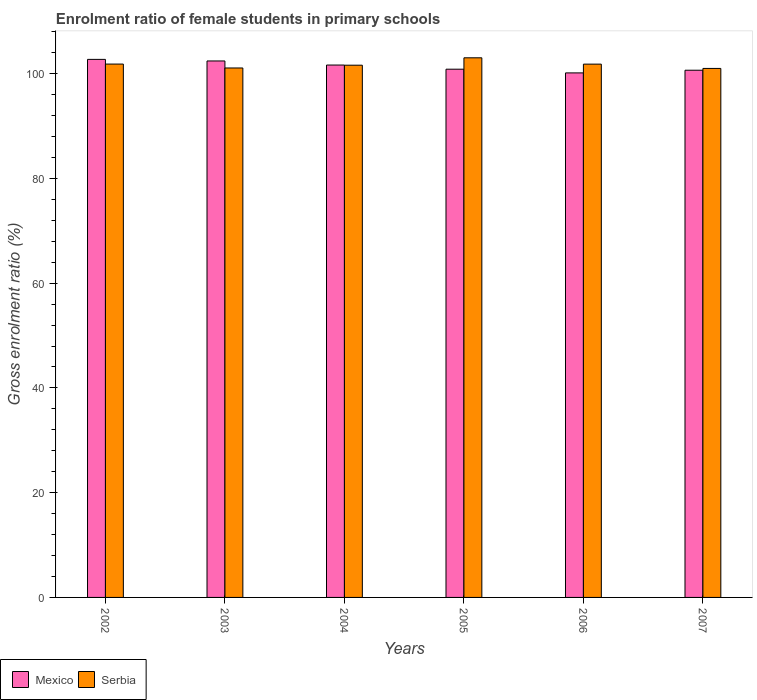How many groups of bars are there?
Make the answer very short. 6. Are the number of bars per tick equal to the number of legend labels?
Your answer should be very brief. Yes. Are the number of bars on each tick of the X-axis equal?
Make the answer very short. Yes. How many bars are there on the 4th tick from the left?
Your response must be concise. 2. What is the enrolment ratio of female students in primary schools in Serbia in 2004?
Give a very brief answer. 101.61. Across all years, what is the maximum enrolment ratio of female students in primary schools in Serbia?
Provide a short and direct response. 103.02. Across all years, what is the minimum enrolment ratio of female students in primary schools in Mexico?
Offer a terse response. 100.14. In which year was the enrolment ratio of female students in primary schools in Mexico maximum?
Your answer should be very brief. 2002. What is the total enrolment ratio of female students in primary schools in Mexico in the graph?
Your answer should be very brief. 608.43. What is the difference between the enrolment ratio of female students in primary schools in Serbia in 2002 and that in 2007?
Your response must be concise. 0.83. What is the difference between the enrolment ratio of female students in primary schools in Mexico in 2007 and the enrolment ratio of female students in primary schools in Serbia in 2004?
Ensure brevity in your answer.  -0.96. What is the average enrolment ratio of female students in primary schools in Mexico per year?
Offer a terse response. 101.4. In the year 2005, what is the difference between the enrolment ratio of female students in primary schools in Mexico and enrolment ratio of female students in primary schools in Serbia?
Your answer should be very brief. -2.17. What is the ratio of the enrolment ratio of female students in primary schools in Mexico in 2002 to that in 2005?
Keep it short and to the point. 1.02. Is the enrolment ratio of female students in primary schools in Mexico in 2005 less than that in 2006?
Make the answer very short. No. What is the difference between the highest and the second highest enrolment ratio of female students in primary schools in Serbia?
Provide a succinct answer. 1.2. What is the difference between the highest and the lowest enrolment ratio of female students in primary schools in Serbia?
Provide a short and direct response. 2.03. In how many years, is the enrolment ratio of female students in primary schools in Serbia greater than the average enrolment ratio of female students in primary schools in Serbia taken over all years?
Your answer should be compact. 3. How many years are there in the graph?
Offer a very short reply. 6. Are the values on the major ticks of Y-axis written in scientific E-notation?
Provide a short and direct response. No. How many legend labels are there?
Your answer should be very brief. 2. What is the title of the graph?
Your answer should be compact. Enrolment ratio of female students in primary schools. What is the label or title of the Y-axis?
Offer a very short reply. Gross enrolment ratio (%). What is the Gross enrolment ratio (%) in Mexico in 2002?
Ensure brevity in your answer.  102.72. What is the Gross enrolment ratio (%) of Serbia in 2002?
Your answer should be very brief. 101.83. What is the Gross enrolment ratio (%) in Mexico in 2003?
Offer a terse response. 102.42. What is the Gross enrolment ratio (%) in Serbia in 2003?
Ensure brevity in your answer.  101.08. What is the Gross enrolment ratio (%) of Mexico in 2004?
Give a very brief answer. 101.64. What is the Gross enrolment ratio (%) of Serbia in 2004?
Give a very brief answer. 101.61. What is the Gross enrolment ratio (%) of Mexico in 2005?
Give a very brief answer. 100.85. What is the Gross enrolment ratio (%) in Serbia in 2005?
Ensure brevity in your answer.  103.02. What is the Gross enrolment ratio (%) in Mexico in 2006?
Give a very brief answer. 100.14. What is the Gross enrolment ratio (%) of Serbia in 2006?
Your answer should be compact. 101.82. What is the Gross enrolment ratio (%) in Mexico in 2007?
Offer a very short reply. 100.65. What is the Gross enrolment ratio (%) of Serbia in 2007?
Your answer should be very brief. 101. Across all years, what is the maximum Gross enrolment ratio (%) in Mexico?
Your answer should be compact. 102.72. Across all years, what is the maximum Gross enrolment ratio (%) in Serbia?
Your response must be concise. 103.02. Across all years, what is the minimum Gross enrolment ratio (%) of Mexico?
Offer a very short reply. 100.14. Across all years, what is the minimum Gross enrolment ratio (%) of Serbia?
Keep it short and to the point. 101. What is the total Gross enrolment ratio (%) in Mexico in the graph?
Your answer should be very brief. 608.43. What is the total Gross enrolment ratio (%) of Serbia in the graph?
Give a very brief answer. 610.36. What is the difference between the Gross enrolment ratio (%) of Mexico in 2002 and that in 2003?
Provide a short and direct response. 0.3. What is the difference between the Gross enrolment ratio (%) of Serbia in 2002 and that in 2003?
Make the answer very short. 0.75. What is the difference between the Gross enrolment ratio (%) in Mexico in 2002 and that in 2004?
Offer a very short reply. 1.08. What is the difference between the Gross enrolment ratio (%) in Serbia in 2002 and that in 2004?
Offer a very short reply. 0.22. What is the difference between the Gross enrolment ratio (%) of Mexico in 2002 and that in 2005?
Offer a very short reply. 1.87. What is the difference between the Gross enrolment ratio (%) of Serbia in 2002 and that in 2005?
Provide a succinct answer. -1.2. What is the difference between the Gross enrolment ratio (%) of Mexico in 2002 and that in 2006?
Provide a succinct answer. 2.58. What is the difference between the Gross enrolment ratio (%) in Serbia in 2002 and that in 2006?
Make the answer very short. 0.01. What is the difference between the Gross enrolment ratio (%) of Mexico in 2002 and that in 2007?
Your answer should be compact. 2.07. What is the difference between the Gross enrolment ratio (%) in Serbia in 2002 and that in 2007?
Ensure brevity in your answer.  0.83. What is the difference between the Gross enrolment ratio (%) in Mexico in 2003 and that in 2004?
Make the answer very short. 0.78. What is the difference between the Gross enrolment ratio (%) of Serbia in 2003 and that in 2004?
Keep it short and to the point. -0.53. What is the difference between the Gross enrolment ratio (%) in Mexico in 2003 and that in 2005?
Give a very brief answer. 1.57. What is the difference between the Gross enrolment ratio (%) of Serbia in 2003 and that in 2005?
Offer a terse response. -1.94. What is the difference between the Gross enrolment ratio (%) in Mexico in 2003 and that in 2006?
Your answer should be very brief. 2.28. What is the difference between the Gross enrolment ratio (%) in Serbia in 2003 and that in 2006?
Your answer should be compact. -0.73. What is the difference between the Gross enrolment ratio (%) in Mexico in 2003 and that in 2007?
Provide a succinct answer. 1.77. What is the difference between the Gross enrolment ratio (%) of Serbia in 2003 and that in 2007?
Provide a short and direct response. 0.09. What is the difference between the Gross enrolment ratio (%) of Mexico in 2004 and that in 2005?
Provide a short and direct response. 0.79. What is the difference between the Gross enrolment ratio (%) in Serbia in 2004 and that in 2005?
Your answer should be very brief. -1.41. What is the difference between the Gross enrolment ratio (%) of Mexico in 2004 and that in 2006?
Provide a succinct answer. 1.5. What is the difference between the Gross enrolment ratio (%) in Serbia in 2004 and that in 2006?
Offer a terse response. -0.2. What is the difference between the Gross enrolment ratio (%) of Mexico in 2004 and that in 2007?
Make the answer very short. 0.99. What is the difference between the Gross enrolment ratio (%) of Serbia in 2004 and that in 2007?
Ensure brevity in your answer.  0.62. What is the difference between the Gross enrolment ratio (%) of Mexico in 2005 and that in 2006?
Your answer should be compact. 0.71. What is the difference between the Gross enrolment ratio (%) in Serbia in 2005 and that in 2006?
Keep it short and to the point. 1.21. What is the difference between the Gross enrolment ratio (%) in Mexico in 2005 and that in 2007?
Give a very brief answer. 0.2. What is the difference between the Gross enrolment ratio (%) of Serbia in 2005 and that in 2007?
Give a very brief answer. 2.03. What is the difference between the Gross enrolment ratio (%) in Mexico in 2006 and that in 2007?
Your answer should be compact. -0.51. What is the difference between the Gross enrolment ratio (%) of Serbia in 2006 and that in 2007?
Make the answer very short. 0.82. What is the difference between the Gross enrolment ratio (%) of Mexico in 2002 and the Gross enrolment ratio (%) of Serbia in 2003?
Provide a succinct answer. 1.64. What is the difference between the Gross enrolment ratio (%) in Mexico in 2002 and the Gross enrolment ratio (%) in Serbia in 2004?
Keep it short and to the point. 1.11. What is the difference between the Gross enrolment ratio (%) of Mexico in 2002 and the Gross enrolment ratio (%) of Serbia in 2005?
Give a very brief answer. -0.3. What is the difference between the Gross enrolment ratio (%) of Mexico in 2002 and the Gross enrolment ratio (%) of Serbia in 2006?
Provide a succinct answer. 0.91. What is the difference between the Gross enrolment ratio (%) of Mexico in 2002 and the Gross enrolment ratio (%) of Serbia in 2007?
Your answer should be compact. 1.73. What is the difference between the Gross enrolment ratio (%) in Mexico in 2003 and the Gross enrolment ratio (%) in Serbia in 2004?
Your response must be concise. 0.81. What is the difference between the Gross enrolment ratio (%) in Mexico in 2003 and the Gross enrolment ratio (%) in Serbia in 2005?
Your response must be concise. -0.6. What is the difference between the Gross enrolment ratio (%) in Mexico in 2003 and the Gross enrolment ratio (%) in Serbia in 2006?
Give a very brief answer. 0.61. What is the difference between the Gross enrolment ratio (%) of Mexico in 2003 and the Gross enrolment ratio (%) of Serbia in 2007?
Ensure brevity in your answer.  1.43. What is the difference between the Gross enrolment ratio (%) of Mexico in 2004 and the Gross enrolment ratio (%) of Serbia in 2005?
Keep it short and to the point. -1.38. What is the difference between the Gross enrolment ratio (%) in Mexico in 2004 and the Gross enrolment ratio (%) in Serbia in 2006?
Offer a very short reply. -0.17. What is the difference between the Gross enrolment ratio (%) of Mexico in 2004 and the Gross enrolment ratio (%) of Serbia in 2007?
Provide a short and direct response. 0.65. What is the difference between the Gross enrolment ratio (%) of Mexico in 2005 and the Gross enrolment ratio (%) of Serbia in 2006?
Provide a succinct answer. -0.97. What is the difference between the Gross enrolment ratio (%) in Mexico in 2005 and the Gross enrolment ratio (%) in Serbia in 2007?
Give a very brief answer. -0.15. What is the difference between the Gross enrolment ratio (%) in Mexico in 2006 and the Gross enrolment ratio (%) in Serbia in 2007?
Offer a terse response. -0.85. What is the average Gross enrolment ratio (%) in Mexico per year?
Offer a terse response. 101.4. What is the average Gross enrolment ratio (%) of Serbia per year?
Offer a very short reply. 101.73. In the year 2002, what is the difference between the Gross enrolment ratio (%) in Mexico and Gross enrolment ratio (%) in Serbia?
Provide a short and direct response. 0.9. In the year 2003, what is the difference between the Gross enrolment ratio (%) in Mexico and Gross enrolment ratio (%) in Serbia?
Provide a succinct answer. 1.34. In the year 2004, what is the difference between the Gross enrolment ratio (%) of Mexico and Gross enrolment ratio (%) of Serbia?
Offer a terse response. 0.03. In the year 2005, what is the difference between the Gross enrolment ratio (%) of Mexico and Gross enrolment ratio (%) of Serbia?
Your answer should be compact. -2.17. In the year 2006, what is the difference between the Gross enrolment ratio (%) of Mexico and Gross enrolment ratio (%) of Serbia?
Offer a very short reply. -1.67. In the year 2007, what is the difference between the Gross enrolment ratio (%) of Mexico and Gross enrolment ratio (%) of Serbia?
Provide a short and direct response. -0.34. What is the ratio of the Gross enrolment ratio (%) in Mexico in 2002 to that in 2003?
Your answer should be very brief. 1. What is the ratio of the Gross enrolment ratio (%) of Serbia in 2002 to that in 2003?
Your answer should be very brief. 1.01. What is the ratio of the Gross enrolment ratio (%) of Mexico in 2002 to that in 2004?
Keep it short and to the point. 1.01. What is the ratio of the Gross enrolment ratio (%) of Serbia in 2002 to that in 2004?
Ensure brevity in your answer.  1. What is the ratio of the Gross enrolment ratio (%) in Mexico in 2002 to that in 2005?
Keep it short and to the point. 1.02. What is the ratio of the Gross enrolment ratio (%) in Serbia in 2002 to that in 2005?
Keep it short and to the point. 0.99. What is the ratio of the Gross enrolment ratio (%) of Mexico in 2002 to that in 2006?
Offer a very short reply. 1.03. What is the ratio of the Gross enrolment ratio (%) in Mexico in 2002 to that in 2007?
Offer a terse response. 1.02. What is the ratio of the Gross enrolment ratio (%) of Serbia in 2002 to that in 2007?
Your answer should be very brief. 1.01. What is the ratio of the Gross enrolment ratio (%) in Mexico in 2003 to that in 2004?
Your answer should be very brief. 1.01. What is the ratio of the Gross enrolment ratio (%) in Mexico in 2003 to that in 2005?
Make the answer very short. 1.02. What is the ratio of the Gross enrolment ratio (%) in Serbia in 2003 to that in 2005?
Give a very brief answer. 0.98. What is the ratio of the Gross enrolment ratio (%) of Mexico in 2003 to that in 2006?
Provide a succinct answer. 1.02. What is the ratio of the Gross enrolment ratio (%) in Serbia in 2003 to that in 2006?
Give a very brief answer. 0.99. What is the ratio of the Gross enrolment ratio (%) in Mexico in 2003 to that in 2007?
Offer a terse response. 1.02. What is the ratio of the Gross enrolment ratio (%) of Serbia in 2003 to that in 2007?
Provide a succinct answer. 1. What is the ratio of the Gross enrolment ratio (%) in Mexico in 2004 to that in 2005?
Your response must be concise. 1.01. What is the ratio of the Gross enrolment ratio (%) in Serbia in 2004 to that in 2005?
Provide a succinct answer. 0.99. What is the ratio of the Gross enrolment ratio (%) in Serbia in 2004 to that in 2006?
Your answer should be compact. 1. What is the ratio of the Gross enrolment ratio (%) of Mexico in 2004 to that in 2007?
Offer a very short reply. 1.01. What is the ratio of the Gross enrolment ratio (%) in Mexico in 2005 to that in 2006?
Your response must be concise. 1.01. What is the ratio of the Gross enrolment ratio (%) of Serbia in 2005 to that in 2006?
Your answer should be very brief. 1.01. What is the ratio of the Gross enrolment ratio (%) of Mexico in 2005 to that in 2007?
Ensure brevity in your answer.  1. What is the ratio of the Gross enrolment ratio (%) in Serbia in 2005 to that in 2007?
Make the answer very short. 1.02. What is the ratio of the Gross enrolment ratio (%) in Mexico in 2006 to that in 2007?
Provide a succinct answer. 0.99. What is the ratio of the Gross enrolment ratio (%) of Serbia in 2006 to that in 2007?
Provide a succinct answer. 1.01. What is the difference between the highest and the second highest Gross enrolment ratio (%) of Mexico?
Provide a succinct answer. 0.3. What is the difference between the highest and the second highest Gross enrolment ratio (%) of Serbia?
Provide a succinct answer. 1.2. What is the difference between the highest and the lowest Gross enrolment ratio (%) of Mexico?
Your response must be concise. 2.58. What is the difference between the highest and the lowest Gross enrolment ratio (%) in Serbia?
Your answer should be very brief. 2.03. 